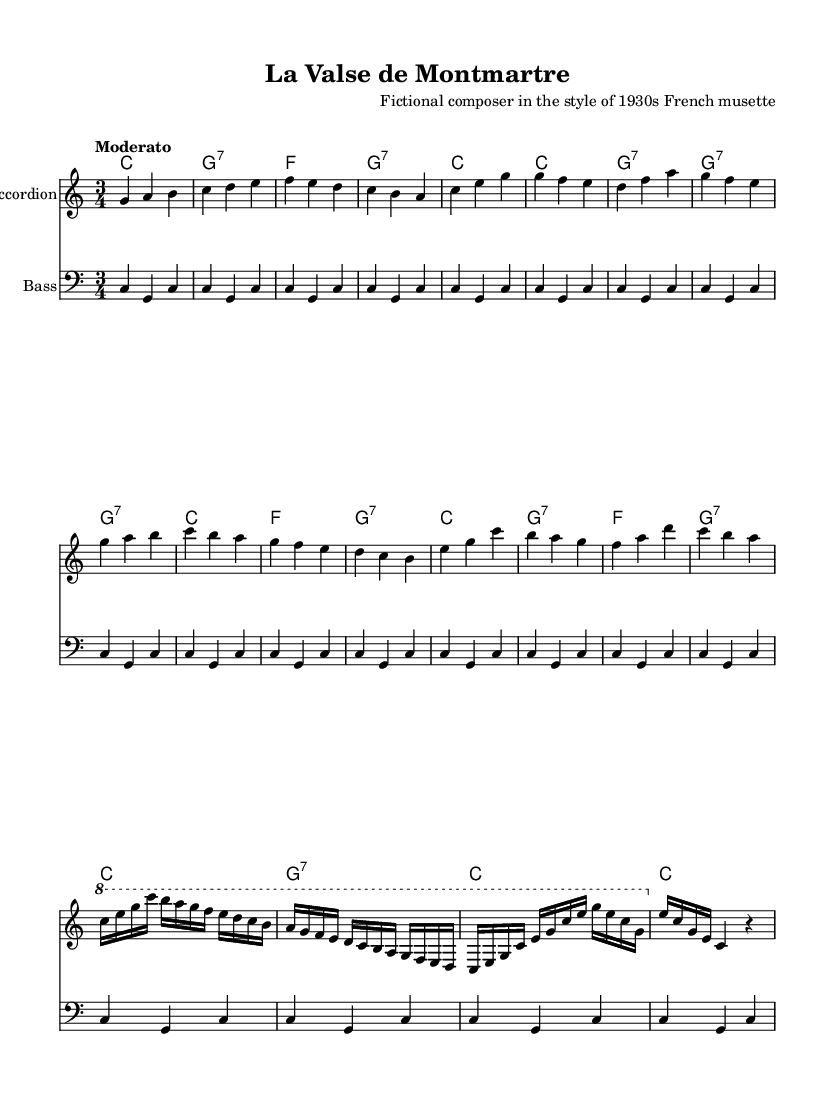What is the key signature of this music? The key signature is C major, which has no sharps or flats, as indicated at the beginning of the score.
Answer: C major What is the time signature of this piece? The time signature is 3/4, shown at the beginning of the score, indicating three beats per measure with a quarter note receiving one beat.
Answer: 3/4 What is the tempo marking of this piece? The tempo marking is "Moderato," which suggests a moderate speed for the piece, specified above the staff.
Answer: Moderato What is the total number of measures in the accordion part? By counting the measures in the accordion part, there are a total of 20 measures noted in the score from the intro to the end of the solo section.
Answer: 20 Which section of the music features an accordion solo? The accordion solo is found in the C section of the score, where it incorporates a variety of notes intended for the accordion as indicated.
Answer: C section How many chords are used in the B section? In the B section, there are four chords used: G7, C, F, and G7, as reflected in the chord names beneath the staff during that section.
Answer: Four 